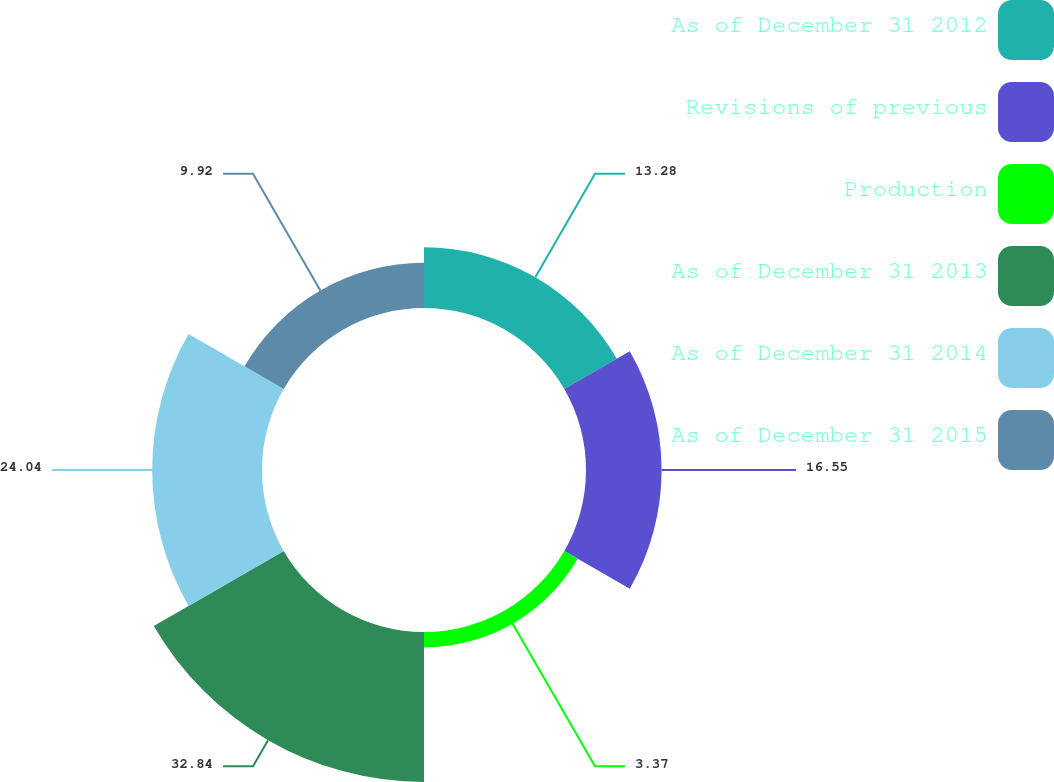Convert chart to OTSL. <chart><loc_0><loc_0><loc_500><loc_500><pie_chart><fcel>As of December 31 2012<fcel>Revisions of previous<fcel>Production<fcel>As of December 31 2013<fcel>As of December 31 2014<fcel>As of December 31 2015<nl><fcel>13.28%<fcel>16.55%<fcel>3.37%<fcel>32.84%<fcel>24.04%<fcel>9.92%<nl></chart> 